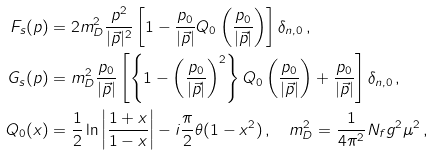Convert formula to latex. <formula><loc_0><loc_0><loc_500><loc_500>F _ { s } ( p ) & = 2 m _ { D } ^ { 2 } \frac { p ^ { 2 } } { | \vec { p } | ^ { 2 } } \left [ 1 - \frac { p _ { 0 } } { | \vec { p } | } Q _ { 0 } \left ( \frac { p _ { 0 } } { | \vec { p } | } \right ) \right ] \delta _ { n , 0 } \, , \\ G _ { s } ( p ) & = m _ { D } ^ { 2 } \frac { p _ { 0 } } { | \vec { p } | } \left [ \left \{ 1 - \left ( \frac { p _ { 0 } } { | \vec { p } | } \right ) ^ { 2 } \right \} Q _ { 0 } \left ( \frac { p _ { 0 } } { | \vec { p } | } \right ) + \frac { p _ { 0 } } { | \vec { p } | } \right ] \delta _ { n , 0 } \, , \\ Q _ { 0 } ( x ) & = \frac { 1 } { 2 } \ln \left | \frac { 1 + x } { 1 - x } \right | - i \frac { \pi } { 2 } \theta ( 1 - x ^ { 2 } ) \, , \quad m _ { D } ^ { 2 } = \frac { 1 } { 4 \pi ^ { 2 } } N _ { f } g ^ { 2 } \mu ^ { 2 } \, ,</formula> 